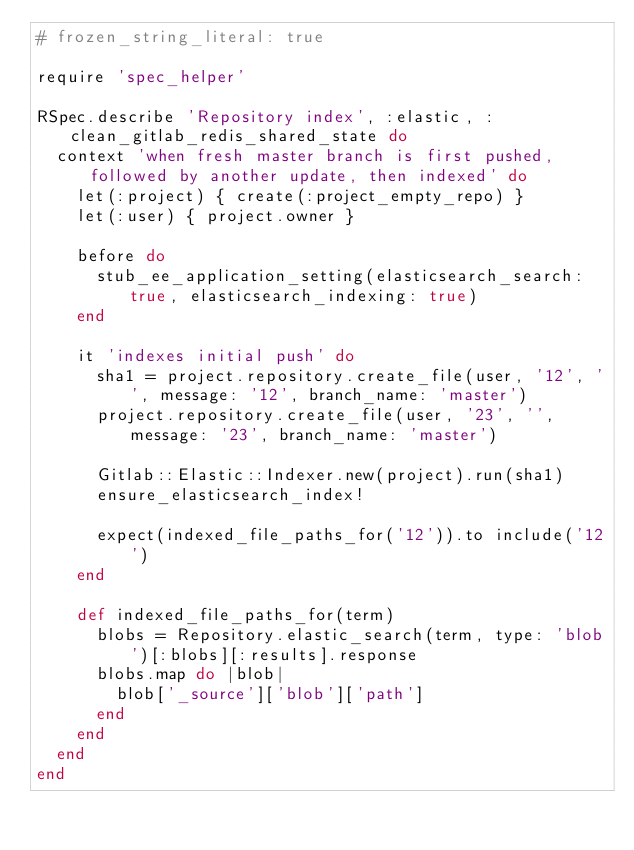<code> <loc_0><loc_0><loc_500><loc_500><_Ruby_># frozen_string_literal: true

require 'spec_helper'

RSpec.describe 'Repository index', :elastic, :clean_gitlab_redis_shared_state do
  context 'when fresh master branch is first pushed, followed by another update, then indexed' do
    let(:project) { create(:project_empty_repo) }
    let(:user) { project.owner }

    before do
      stub_ee_application_setting(elasticsearch_search: true, elasticsearch_indexing: true)
    end

    it 'indexes initial push' do
      sha1 = project.repository.create_file(user, '12', '', message: '12', branch_name: 'master')
      project.repository.create_file(user, '23', '', message: '23', branch_name: 'master')

      Gitlab::Elastic::Indexer.new(project).run(sha1)
      ensure_elasticsearch_index!

      expect(indexed_file_paths_for('12')).to include('12')
    end

    def indexed_file_paths_for(term)
      blobs = Repository.elastic_search(term, type: 'blob')[:blobs][:results].response
      blobs.map do |blob|
        blob['_source']['blob']['path']
      end
    end
  end
end
</code> 